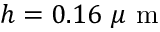<formula> <loc_0><loc_0><loc_500><loc_500>h = 0 . 1 6 \mu m</formula> 